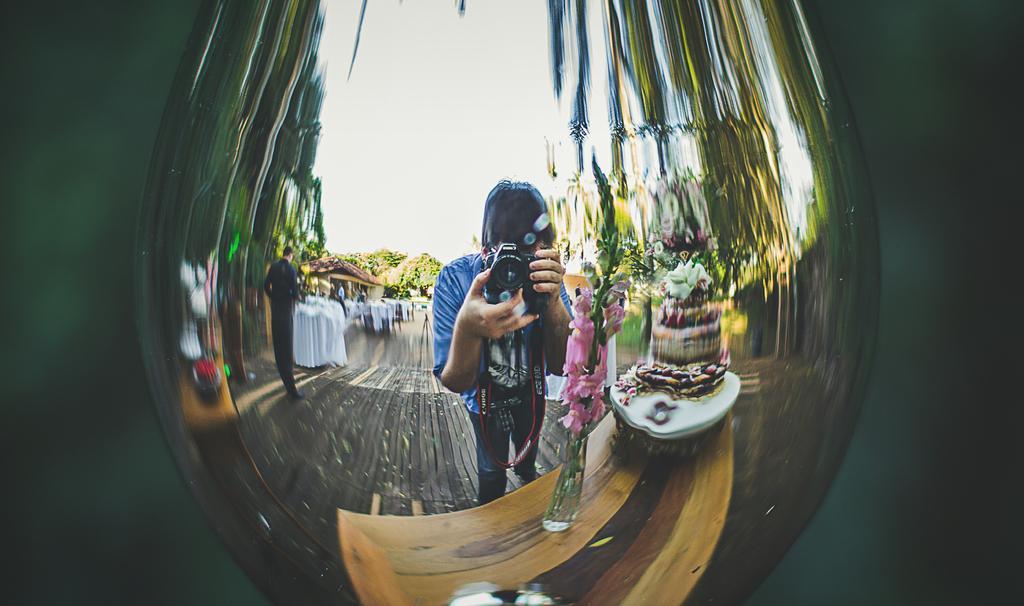In one or two sentences, can you explain what this image depicts? In this image I can see a person holding a camera, the person is wearing blue shirt and blue pant. I can also see the cake in multi color, background I can see few persons standing, trees in green color and the sky is in white color. 